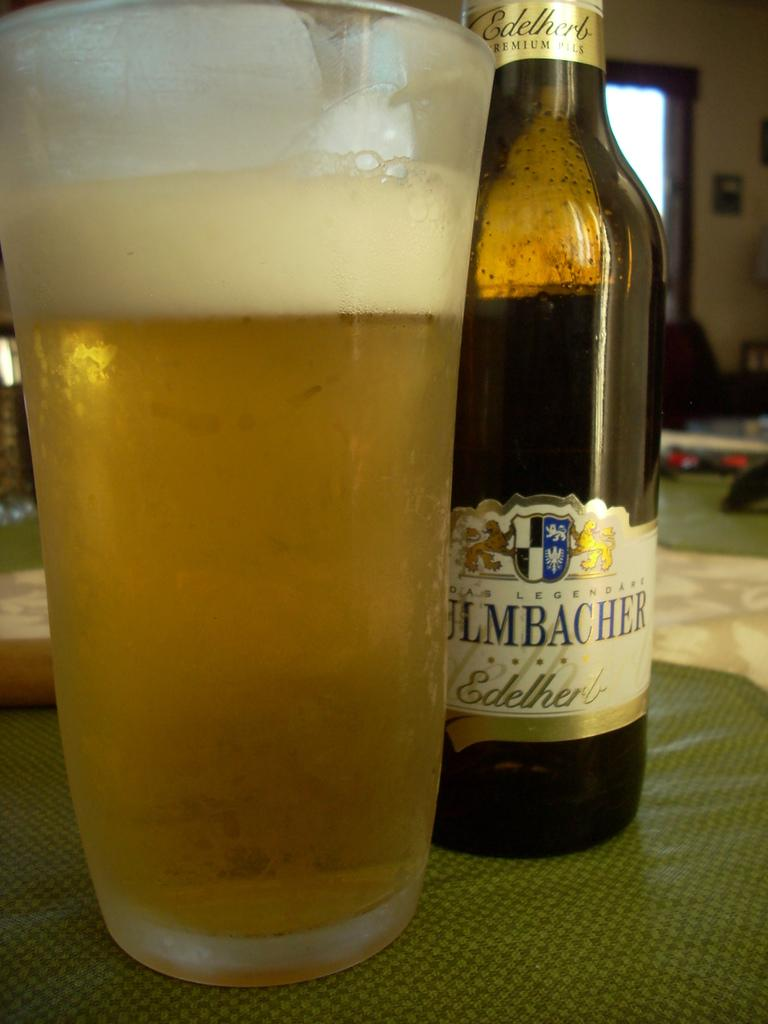<image>
Render a clear and concise summary of the photo. that pilsner beer from edelherle looks very tasty 